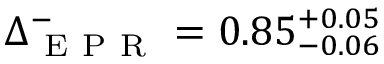<formula> <loc_0><loc_0><loc_500><loc_500>\Delta _ { E P R } ^ { - } = 0 . 8 5 _ { - 0 . 0 6 } ^ { + 0 . 0 5 }</formula> 